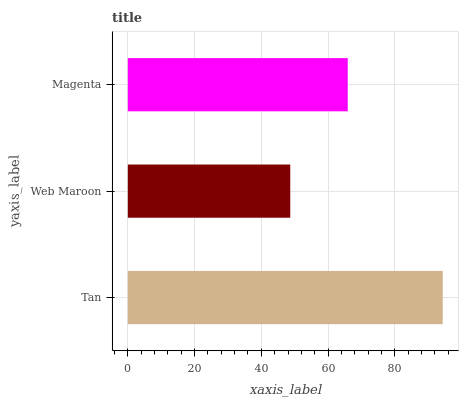Is Web Maroon the minimum?
Answer yes or no. Yes. Is Tan the maximum?
Answer yes or no. Yes. Is Magenta the minimum?
Answer yes or no. No. Is Magenta the maximum?
Answer yes or no. No. Is Magenta greater than Web Maroon?
Answer yes or no. Yes. Is Web Maroon less than Magenta?
Answer yes or no. Yes. Is Web Maroon greater than Magenta?
Answer yes or no. No. Is Magenta less than Web Maroon?
Answer yes or no. No. Is Magenta the high median?
Answer yes or no. Yes. Is Magenta the low median?
Answer yes or no. Yes. Is Web Maroon the high median?
Answer yes or no. No. Is Tan the low median?
Answer yes or no. No. 